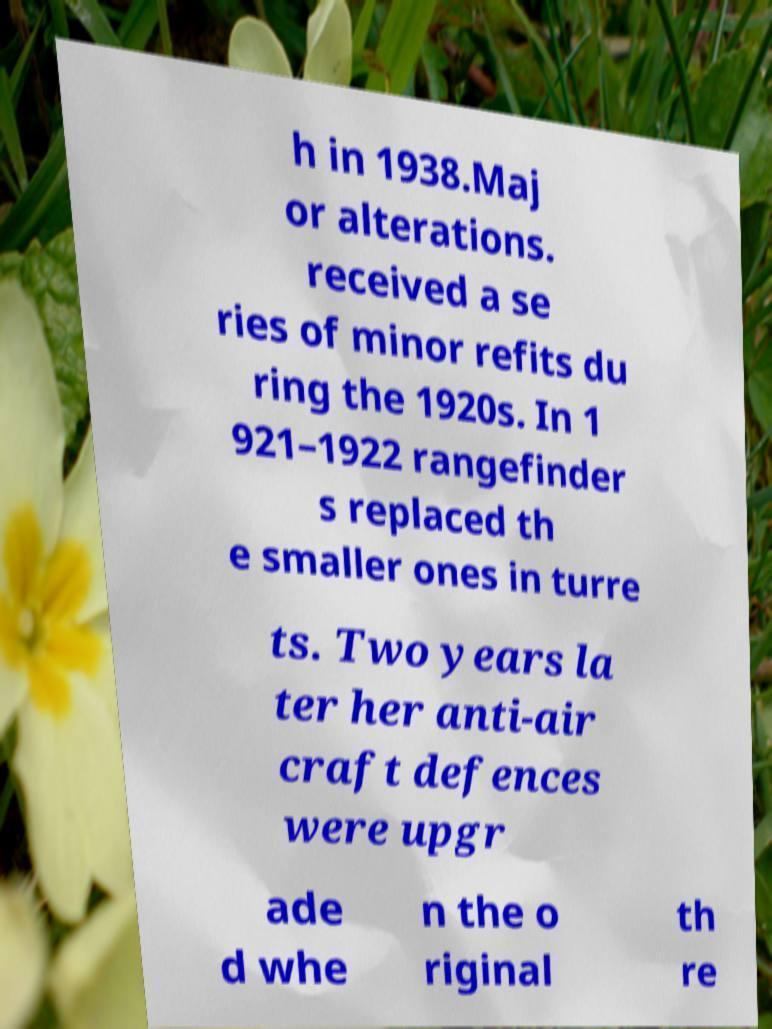Please identify and transcribe the text found in this image. h in 1938.Maj or alterations. received a se ries of minor refits du ring the 1920s. In 1 921–1922 rangefinder s replaced th e smaller ones in turre ts. Two years la ter her anti-air craft defences were upgr ade d whe n the o riginal th re 